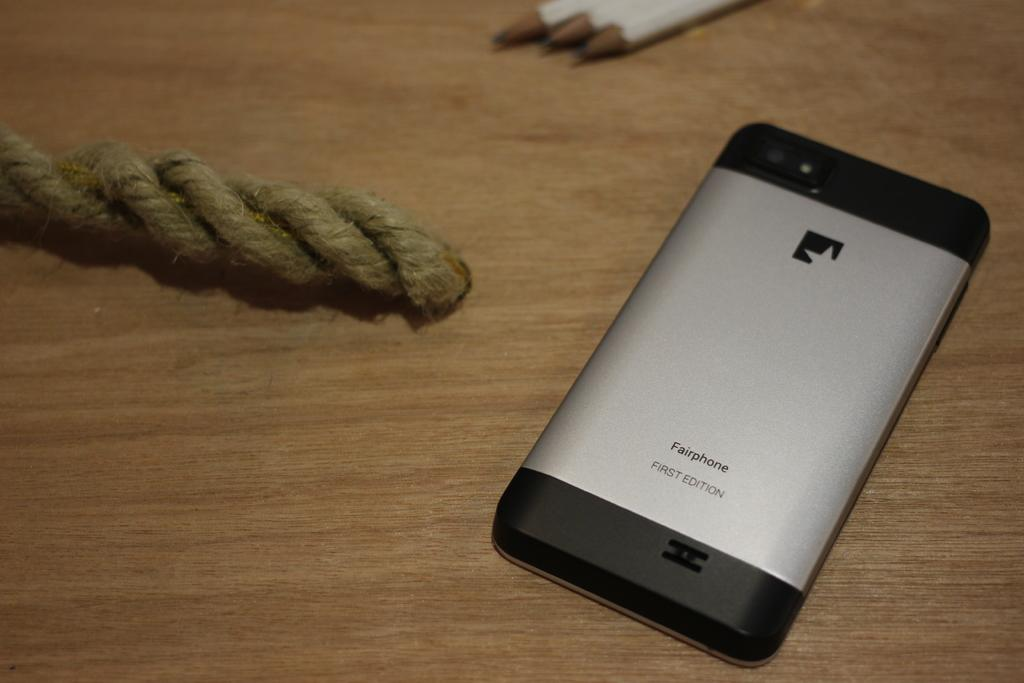<image>
Share a concise interpretation of the image provided. A phone face down on a desk and the word Fairphone on it 